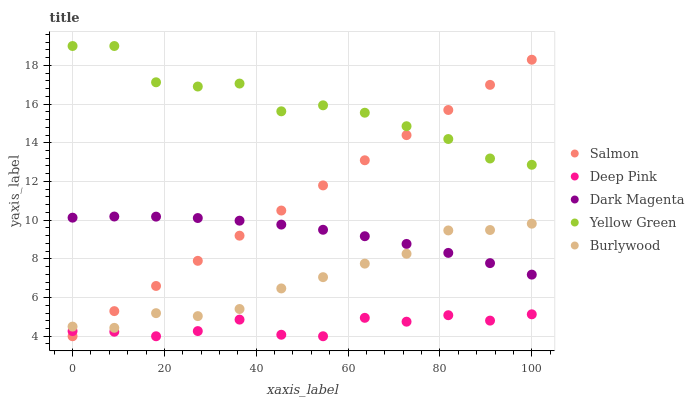Does Deep Pink have the minimum area under the curve?
Answer yes or no. Yes. Does Yellow Green have the maximum area under the curve?
Answer yes or no. Yes. Does Salmon have the minimum area under the curve?
Answer yes or no. No. Does Salmon have the maximum area under the curve?
Answer yes or no. No. Is Salmon the smoothest?
Answer yes or no. Yes. Is Yellow Green the roughest?
Answer yes or no. Yes. Is Deep Pink the smoothest?
Answer yes or no. No. Is Deep Pink the roughest?
Answer yes or no. No. Does Deep Pink have the lowest value?
Answer yes or no. Yes. Does Dark Magenta have the lowest value?
Answer yes or no. No. Does Yellow Green have the highest value?
Answer yes or no. Yes. Does Salmon have the highest value?
Answer yes or no. No. Is Burlywood less than Yellow Green?
Answer yes or no. Yes. Is Yellow Green greater than Deep Pink?
Answer yes or no. Yes. Does Burlywood intersect Salmon?
Answer yes or no. Yes. Is Burlywood less than Salmon?
Answer yes or no. No. Is Burlywood greater than Salmon?
Answer yes or no. No. Does Burlywood intersect Yellow Green?
Answer yes or no. No. 